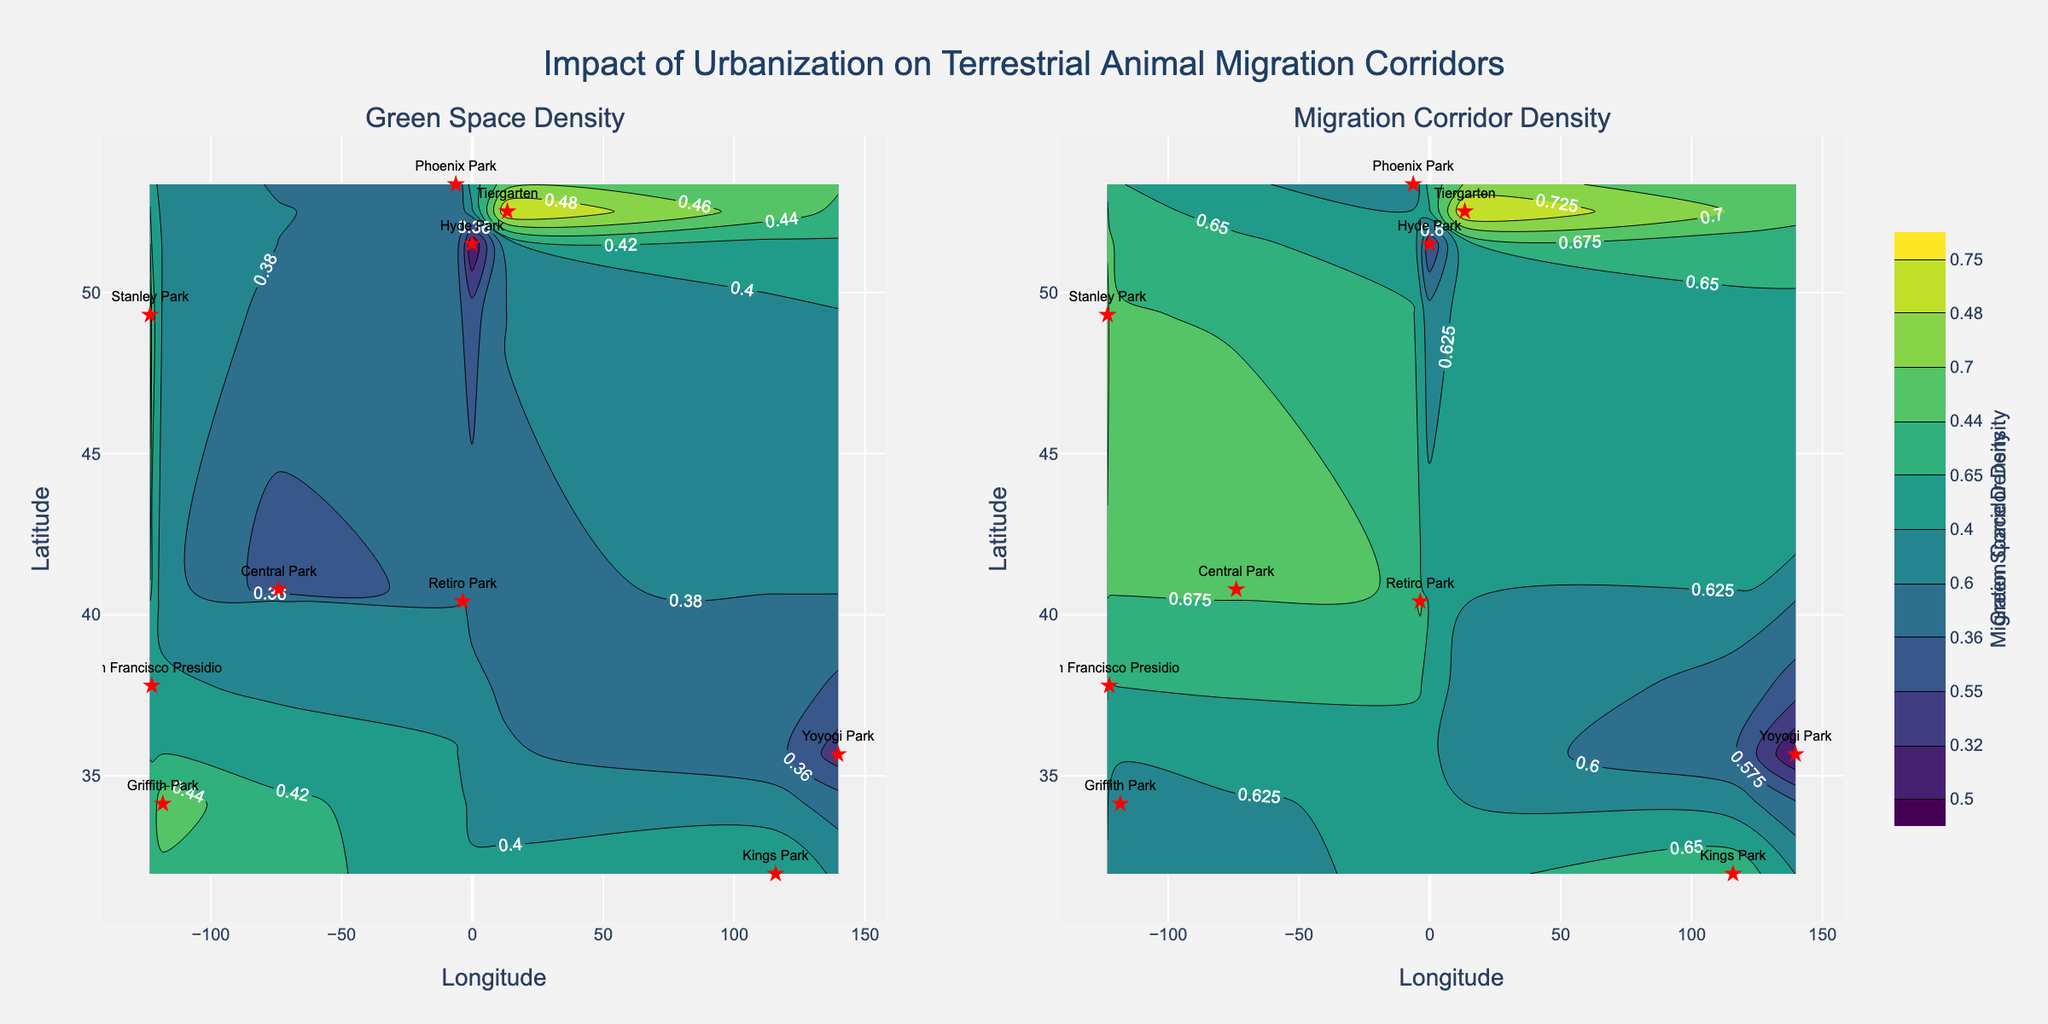Which location has the highest green space density? By looking at the "Green Space Density" contour plot, we can observe that Tiergarten has the highest density, marked by its position on the map and the highest value in the color scale.
Answer: Tiergarten Which subplot shows the migration corridor density? The "Migration Corridor Density" subplot is the second plot titled "Migration Corridor Density" on the right side.
Answer: Second subplot What is the title of the overall figure? The title is displayed at the top center of the figure. It reads "Impact of Urbanization on Terrestrial Animal Migration Corridors".
Answer: Impact of Urbanization on Terrestrial Animal Migration Corridors Which location has both high green space and migration corridor densities? Reviewing both subplots, Tiergarten stands out as having high values on both green space density and migration corridor density plots.
Answer: Tiergarten What color indicates the highest density values on the plots? By examining the color scale, the highest density values are indicated by the deepest green color.
Answer: Deepest green Compare the green space density of Hyde Park and Central Park. Which is higher? From the "Green Space Density" subplot, comparing the locations, Central Park has a higher green space density than Hyde Park.
Answer: Central Park Which location has the lowest migration corridor density? The "Migration Corridor Density" subplot reveals Yoyogi Park has the lowest density, marked by a lower value in the color scale.
Answer: Yoyogi Park Calculate the average green space density value across all locations. Summing the green space density values (0.35 + 0.40 + 0.45 + 0.30 + 0.50 + 0.38 + 0.33 + 0.36 + 0.48 + 0.42) gives 3.97. Dividing by the number of data points (10), the average is 3.97 / 10.
Answer: 0.397 Is there any location that appears to have roughly equal densities for both metrics? By analyzing both subplots, Retiro Park appears to have roughly equal densities, approximately 0.38 for green space and 0.68 for migration corridor, showing them relatively close in value.
Answer: Retiro Park Which subplot has a higher average density overall? Calculating the average migration corridor density (0.70 + 0.65 + 0.60 + 0.55 + 0.75 + 0.68 + 0.50 + 0.60 + 0.72 + 0.67) gives 6.42. Dividing by the number of data points (10) gives 6.42 / 10. Comparing the two averages, the migration corridor density has a higher average of 0.642 compared to 0.397 of green space density.
Answer: Migration corridor density 